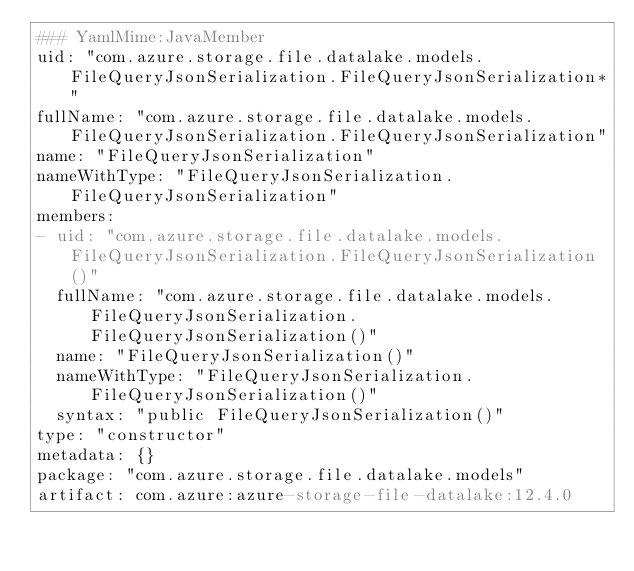Convert code to text. <code><loc_0><loc_0><loc_500><loc_500><_YAML_>### YamlMime:JavaMember
uid: "com.azure.storage.file.datalake.models.FileQueryJsonSerialization.FileQueryJsonSerialization*"
fullName: "com.azure.storage.file.datalake.models.FileQueryJsonSerialization.FileQueryJsonSerialization"
name: "FileQueryJsonSerialization"
nameWithType: "FileQueryJsonSerialization.FileQueryJsonSerialization"
members:
- uid: "com.azure.storage.file.datalake.models.FileQueryJsonSerialization.FileQueryJsonSerialization()"
  fullName: "com.azure.storage.file.datalake.models.FileQueryJsonSerialization.FileQueryJsonSerialization()"
  name: "FileQueryJsonSerialization()"
  nameWithType: "FileQueryJsonSerialization.FileQueryJsonSerialization()"
  syntax: "public FileQueryJsonSerialization()"
type: "constructor"
metadata: {}
package: "com.azure.storage.file.datalake.models"
artifact: com.azure:azure-storage-file-datalake:12.4.0
</code> 